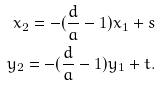Convert formula to latex. <formula><loc_0><loc_0><loc_500><loc_500>x _ { 2 } = - ( \frac { d } { a } - 1 ) x _ { 1 } + s \\ y _ { 2 } = - ( \frac { d } { a } - 1 ) y _ { 1 } + t .</formula> 